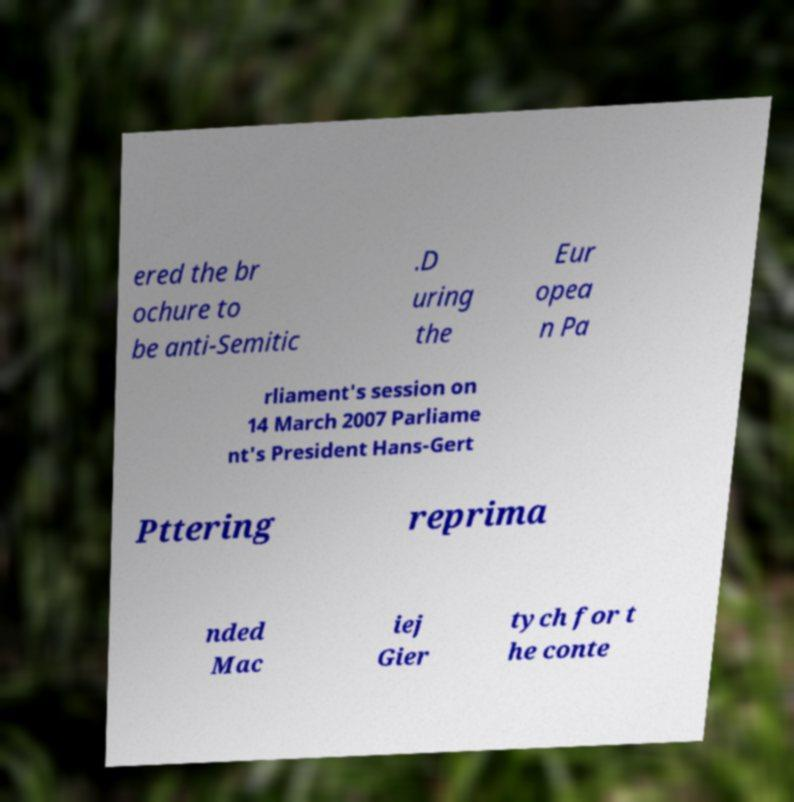Can you read and provide the text displayed in the image?This photo seems to have some interesting text. Can you extract and type it out for me? ered the br ochure to be anti-Semitic .D uring the Eur opea n Pa rliament's session on 14 March 2007 Parliame nt's President Hans-Gert Pttering reprima nded Mac iej Gier tych for t he conte 